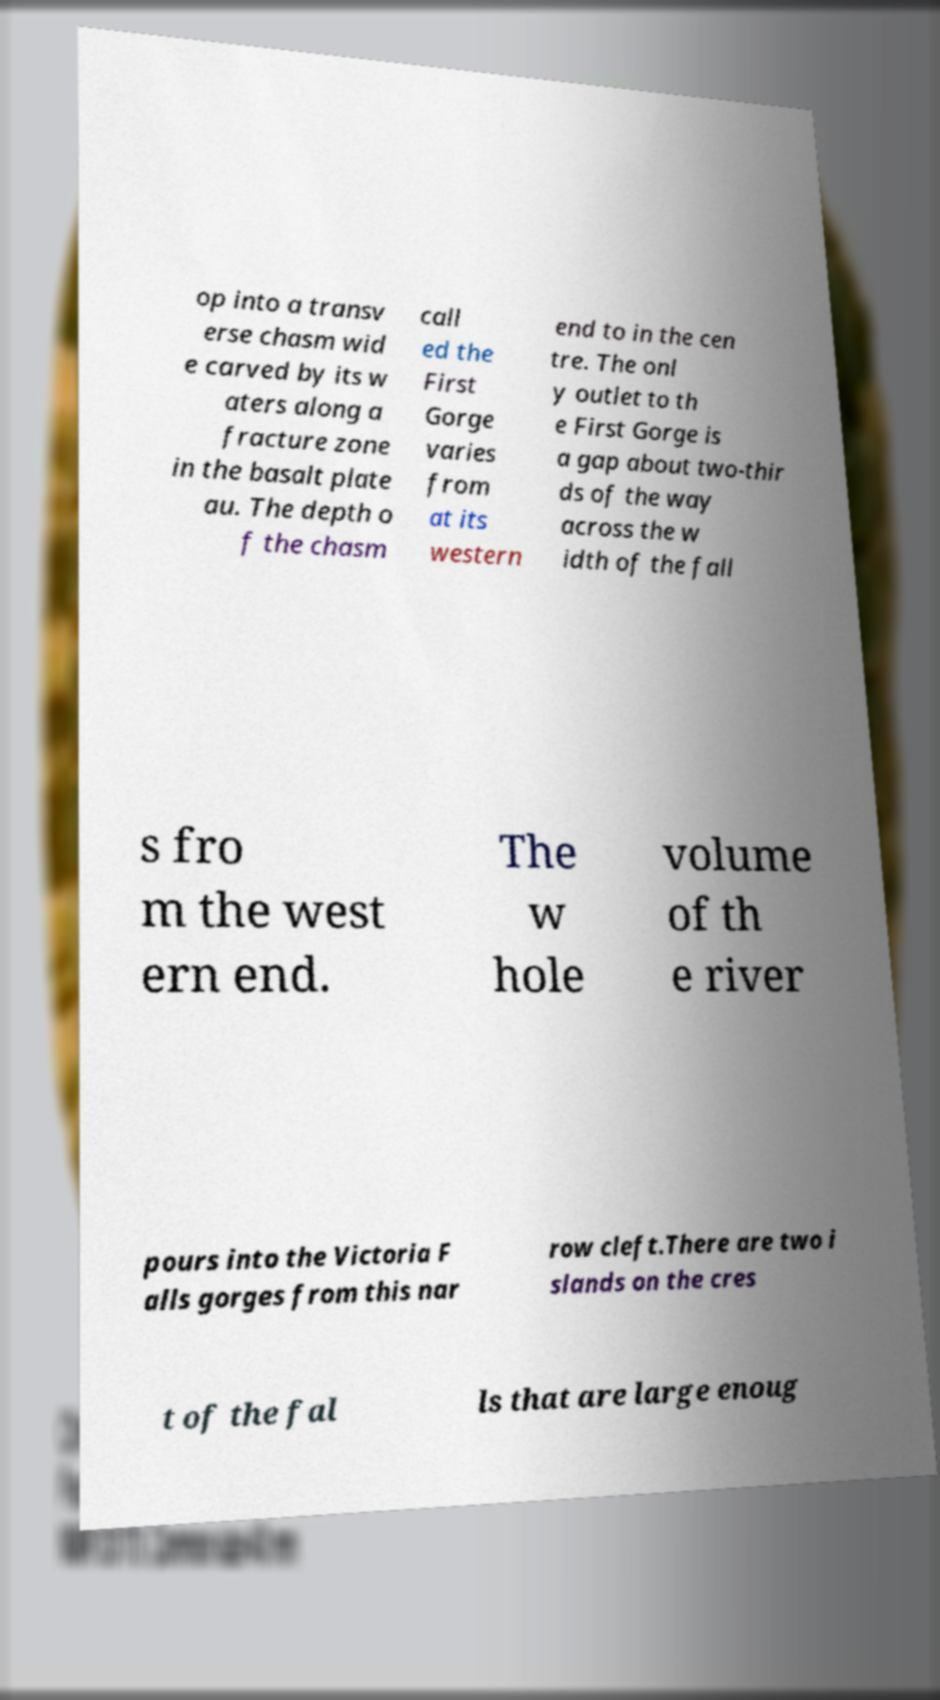Could you assist in decoding the text presented in this image and type it out clearly? op into a transv erse chasm wid e carved by its w aters along a fracture zone in the basalt plate au. The depth o f the chasm call ed the First Gorge varies from at its western end to in the cen tre. The onl y outlet to th e First Gorge is a gap about two-thir ds of the way across the w idth of the fall s fro m the west ern end. The w hole volume of th e river pours into the Victoria F alls gorges from this nar row cleft.There are two i slands on the cres t of the fal ls that are large enoug 